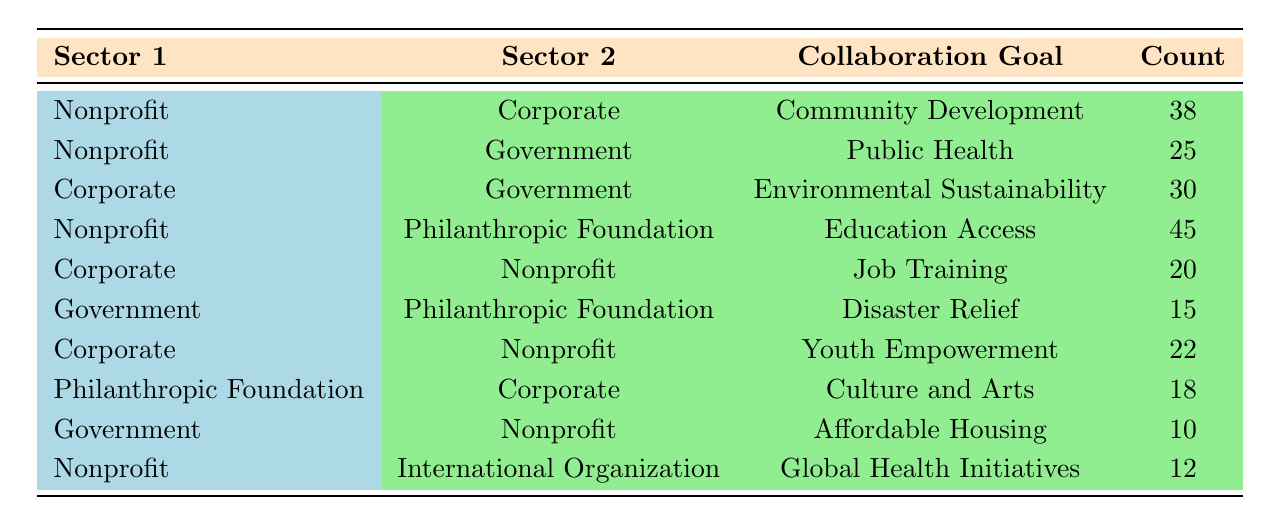What is the collaboration goal for the partnership between Nonprofit and Corporate? The table specifies the collaboration goal for each partnership. Looking at the row where Sector 1 is Nonprofit and Sector 2 is Corporate, the collaboration goal listed is Community Development.
Answer: Community Development How many partnerships are there involving the Government sector? To find the number of partnerships involving Government, we count all rows where either Sector 1 or Sector 2 is Government. There are 3 partnerships: (Nonprofit-Government), (Corporate-Government), and (Government-Philanthropic Foundation).
Answer: 3 Which collaboration goal has the highest count and what is the count? We examine the counts for each collaboration goal listed in the table. The values are 38 (Community Development), 25 (Public Health), 30 (Environmental Sustainability), 45 (Education Access), 20 (Job Training), 15 (Disaster Relief), 22 (Youth Empowerment), 18 (Culture and Arts), 10 (Affordable Housing), and 12 (Global Health Initiatives). The highest count is 45 for Education Access.
Answer: Education Access, 45 Is there a partnership between Philanthropic Foundation and Government? A quick look through the table reveals that there are no rows showing a partnership where Sector 1 is Philanthropic Foundation and Sector 2 is Government. Thus, the statement is false.
Answer: No What is the total count of partnerships that focus on Education Access and Youth Empowerment? We first identify the counts for each of these collaboration goals. The count for Education Access (Nonprofit - Philanthropic Foundation) is 45. The count for Youth Empowerment (Corporate - Nonprofit) is 22. Then we sum these counts: 45 + 22 = 67.
Answer: 67 What percentage of partnerships aimed at community development are between Nonprofit and Corporate? There is 1 partnership aimed at community development, which is between Nonprofit and Corporate, with a count of 38. To find the percentage, we divide that by the total partnerships, which is 10 (as represented by the total count of unique rows) and multiply by 100. The formula is (38/10) * 100 = 380%.
Answer: 380% How many partnerships have a goal related to health? We check the collaboration goals in the table. The relevant goals are Public Health (25) and Global Health Initiatives (12), which sum to 37. Thus, the total number of partnerships aimed at health-related goals is 25 + 12 = 37.
Answer: 37 Which sector pairs have a partnership with a count lower than 20? Looking through the table, we identify partnerships with counts: (Government - Nonprofit) 10, (Government - Philanthropic Foundation) 15, and (Corporate - Nonprofit) 20 (not lower since it's exactly 20). Only the partnerships with counts of 10 and 15 are below 20, resulting in 2 partnerships: (Government - Nonprofit) and (Government - Philanthropic Foundation).
Answer: 2 partnerships Do any partnerships focus on Job Training? The table lists a partnership between Corporate and Nonprofit specifically for Job Training, confirming the existence of such a partnership.
Answer: Yes 